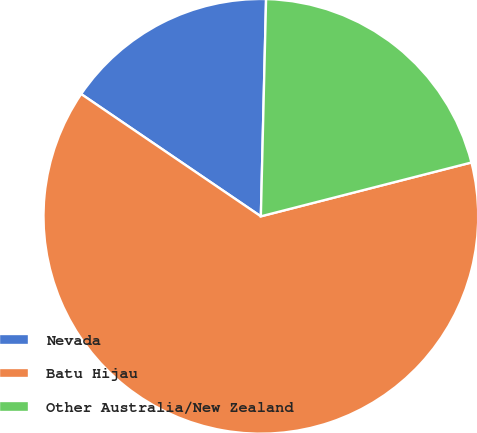<chart> <loc_0><loc_0><loc_500><loc_500><pie_chart><fcel>Nevada<fcel>Batu Hijau<fcel>Other Australia/New Zealand<nl><fcel>15.87%<fcel>63.49%<fcel>20.63%<nl></chart> 